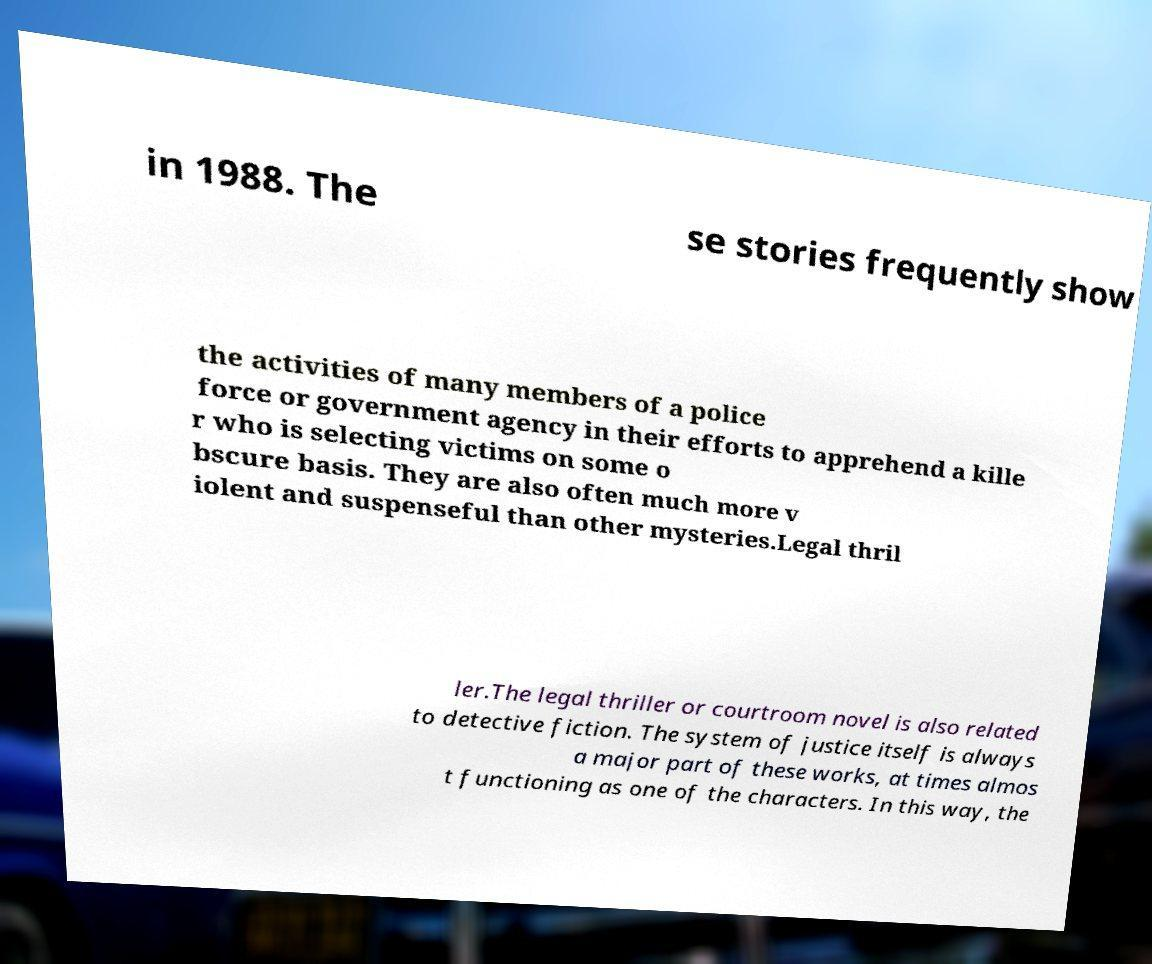For documentation purposes, I need the text within this image transcribed. Could you provide that? in 1988. The se stories frequently show the activities of many members of a police force or government agency in their efforts to apprehend a kille r who is selecting victims on some o bscure basis. They are also often much more v iolent and suspenseful than other mysteries.Legal thril ler.The legal thriller or courtroom novel is also related to detective fiction. The system of justice itself is always a major part of these works, at times almos t functioning as one of the characters. In this way, the 